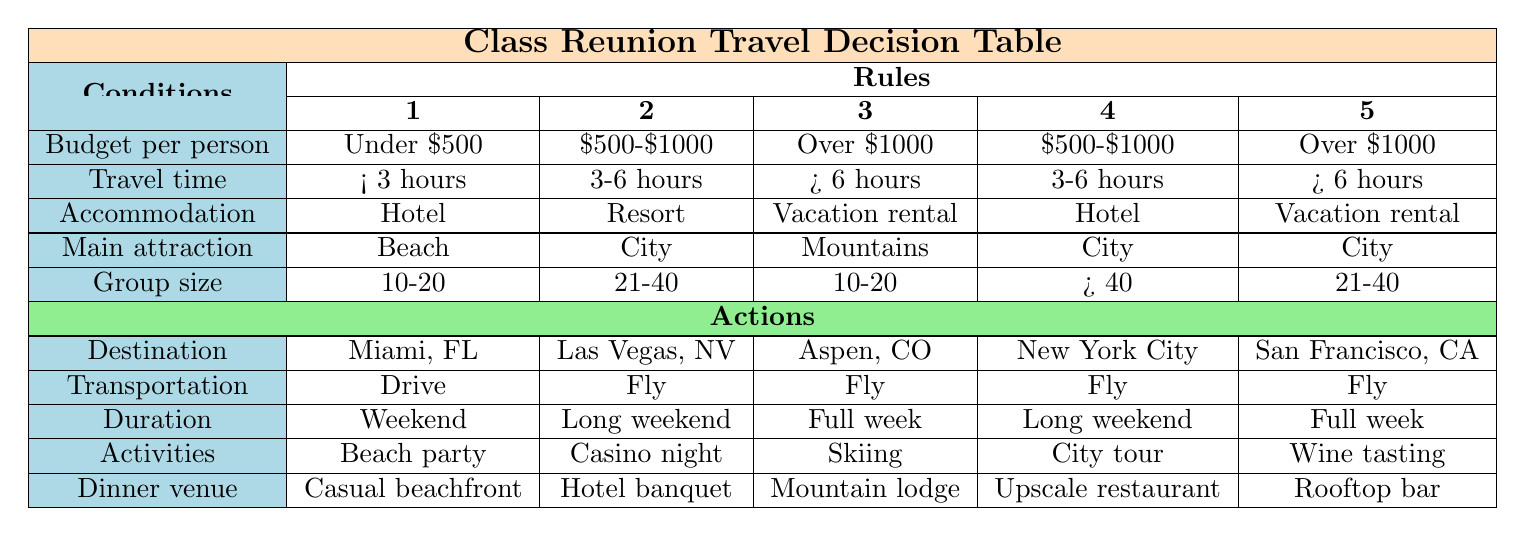What travel destination is suggested for a group of over 40 people with a budget of $500-$1000? In the table, we look under the "Budget per person" for "$500-$1000" and find the corresponding row for "Group size" over 40 people. It leads us to rule 4, which suggests "New York City".
Answer: New York City What type of accommodation is recommended for a beach destination within 3 hours of travel? By examining the conditions, we check the "Main attraction" as "Beach", "Travel time" as "Less than 3 hours", and find that rule 1 suggests "Hotel" for "Miami, Florida".
Answer: Hotel Is skiing an organized activity for the group traveling to Aspen, Colorado? We determine the destination through rule 3, which confirms that skiing is indeed suggested as the organized activity for Aspen, Colorado.
Answer: Yes Which destination has the longest duration for a vacation rental in the mountains? We look for "Over 6 hours" for "Travel time" and "Vacation rental" for "Accommodation type," leading us to rule 3, which mentions a "Full week" at Aspen, Colorado.
Answer: Aspen, Colorado How many different transportation options are available for destinations with a budget of over $1000? We check the rules for any actions that match "$1000", which are rules 3 and 5. Both suggest 'Fly' as the transportation option, indicating that there is only one choice here.
Answer: 1 